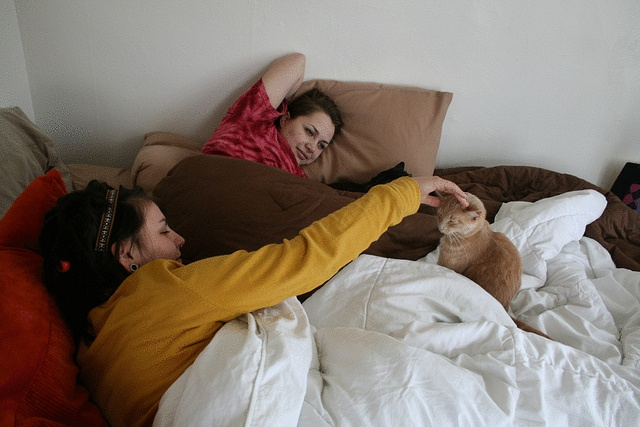Describe the objects in this image and their specific colors. I can see bed in gray, darkgray, lightgray, and black tones, people in gray, black, olive, and maroon tones, people in gray, black, maroon, and darkgray tones, cat in gray and maroon tones, and cat in gray, black, maroon, and olive tones in this image. 